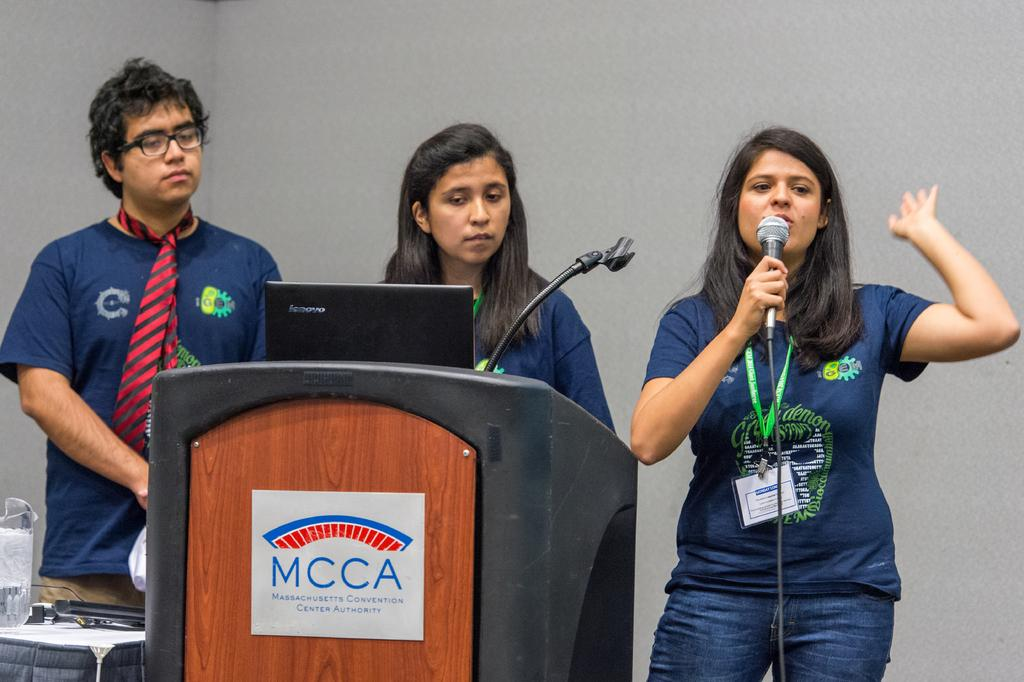How many people are present in the image? There are three people in the image: one man and two women. What is the woman holding in the image? One of the women is holding a mic. What is the woman with the mic standing near? The woman holding the mic is standing in front of a podium. What can be seen in the background of the image? There is a wall visible in the background of the image. How many spiders are crawling on the wall in the image? There are no spiders visible in the image; only a wall can be seen in the background. What type of porter is serving drinks in the image? There is no porter present in the image, nor is there any indication of drinks being served. 